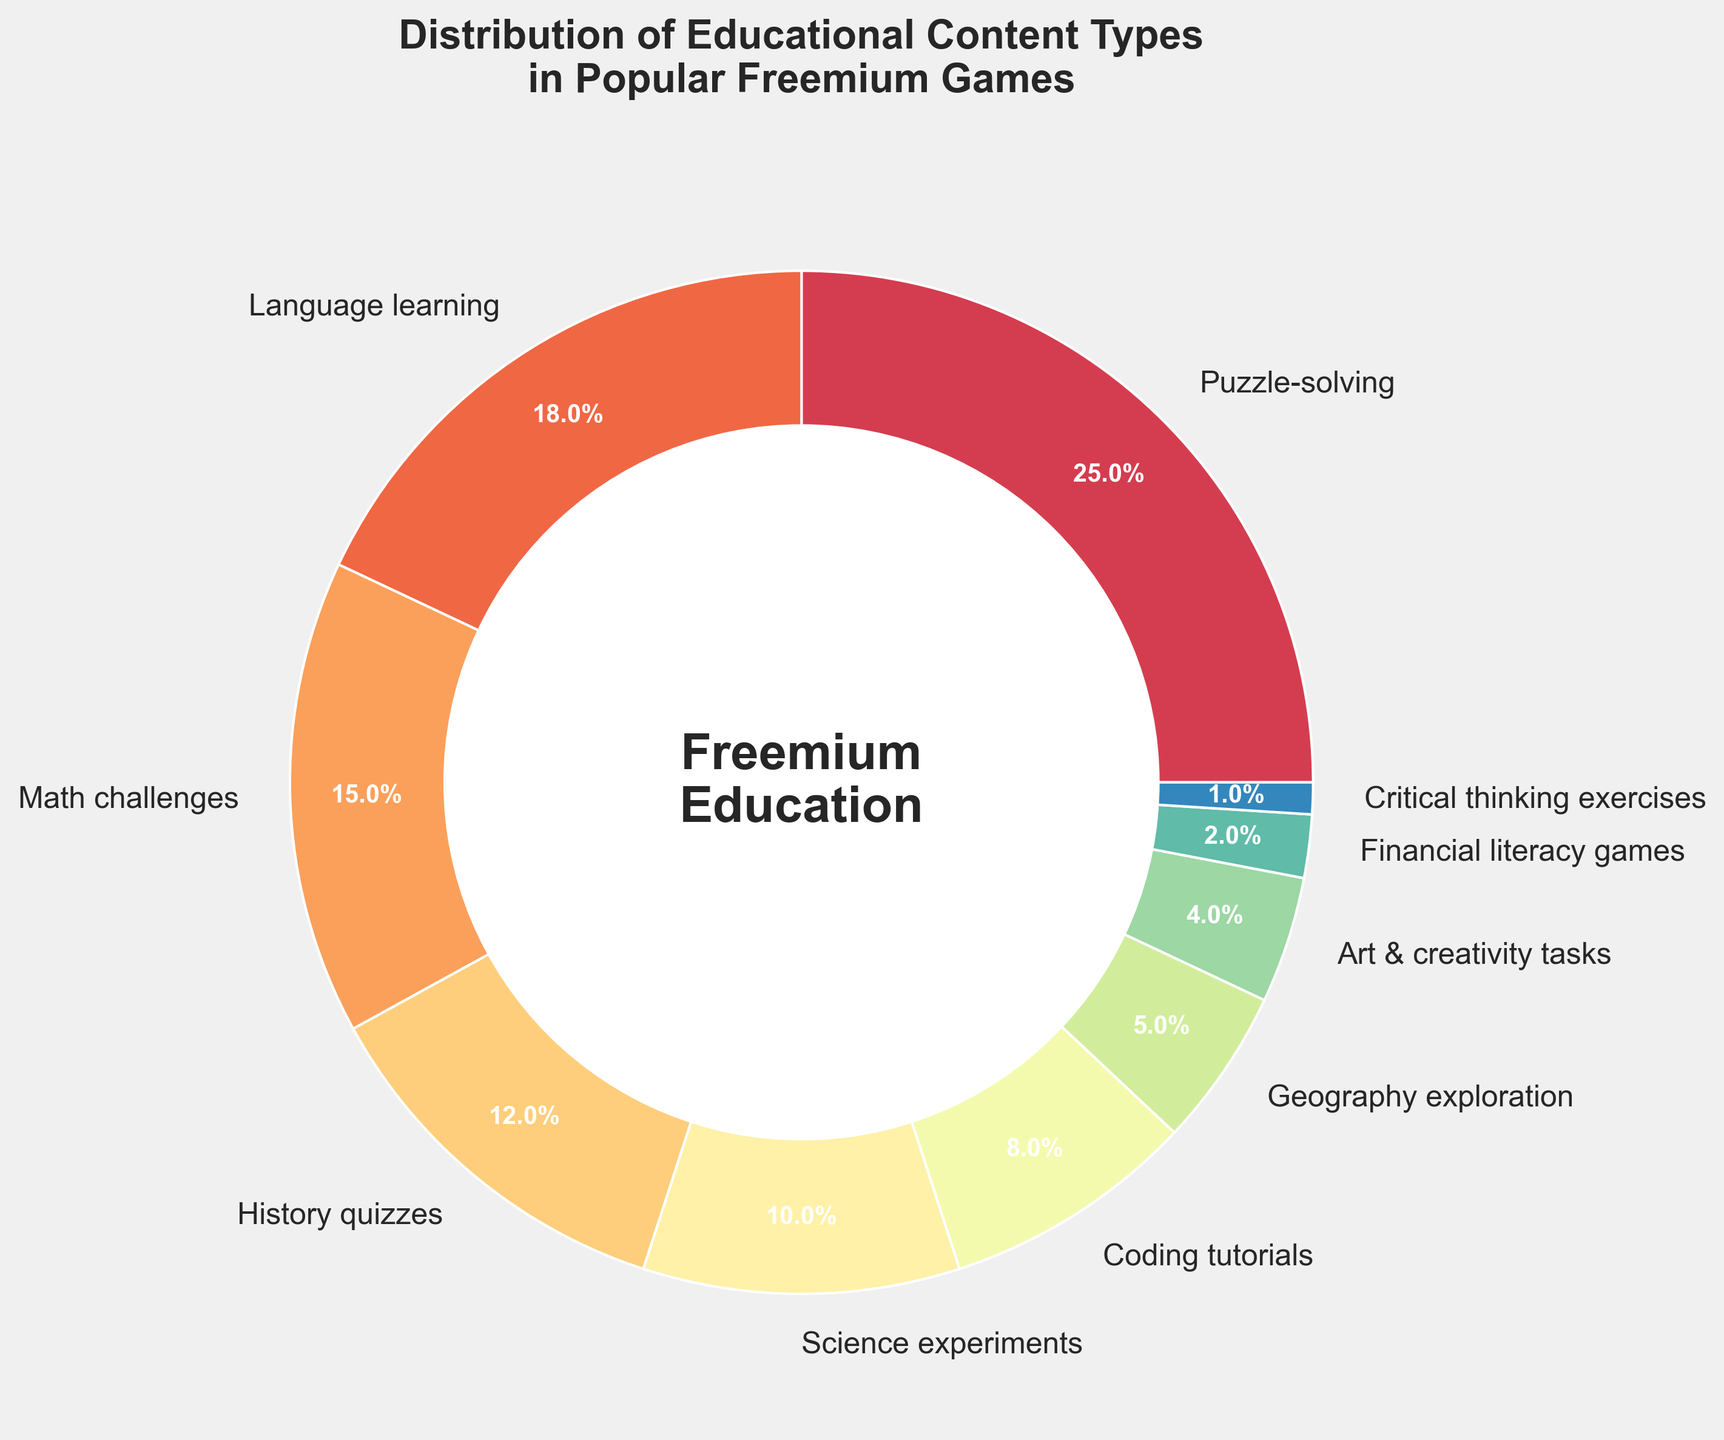What's the most common type of educational content in popular freemium games? Look at the largest pie slice, which represents the highest percentage.
Answer: Puzzle-solving What percentage of content in popular freemium games is dedicated to language learning? Check the segment labeled "Language learning" for its percentage.
Answer: 18% How much more popular are puzzle-solving games compared to math challenges? Subtract the percentage for Math challenges from the percentage for Puzzle-solving. (25% - 15% = 10%)
Answer: 10% Which educational content types collectively make up more than half of the total content? Add up the percentages of the content types from the largest until the sum exceeds 50%. (Puzzle-solving 25% + Language learning 18% + Math challenges 15% = 58%)
Answer: Puzzle-solving, Language learning, Math challenges What is the least common type of educational content? Look for the smallest pie slice, which represents the lowest percentage.
Answer: Critical thinking exercises Compare the combined percentage of Language learning and Science experiments to Puzzle-solving. Which is higher? Add the percentages for Language learning and Science experiments (18% + 10% = 28%) and compare to that of Puzzle-solving (25%).
Answer: Language learning and Science experiments Among Math challenges, History quizzes, and Geography exploration, which type has the intermediate percentage? Arrange percentages of Math challenges (15%), History quizzes (12%), and Geography exploration (5%) and find the middle value.
Answer: History quizzes What's the total percentage of content focused on STEM (Science, Technology, Engineering, Math) subjects in freemium games? Add percentages for Math challenges, Science experiments, and Coding tutorials. (15% + 10% + 8% = 33%)
Answer: 33% What is the visual attribute of the central circle in the pie chart? Observing the central area of the chart, the circle's color, and any text inside it.
Answer: White with "Freemium\nEducation" text How much bigger is the Art & creativity tasks percentage compared to Financial literacy games? Subtract the percentage of Financial literacy games from the percentage of Art & creativity tasks. (4% - 2% = 2%)
Answer: 2% 